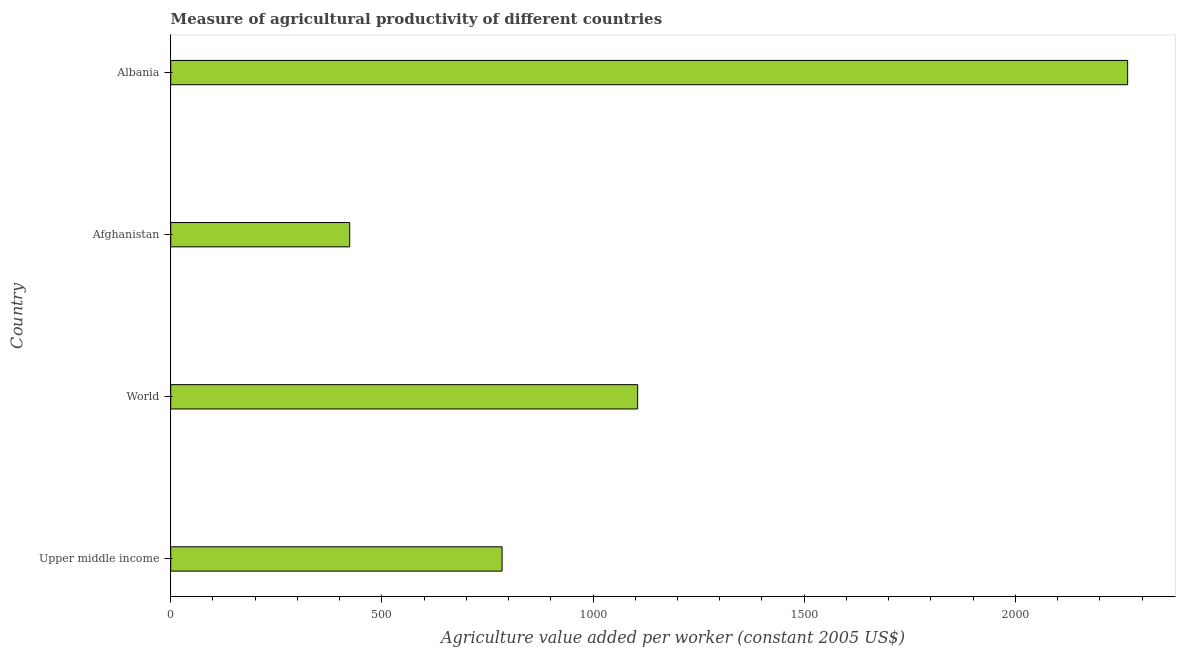Does the graph contain any zero values?
Provide a short and direct response. No. What is the title of the graph?
Your answer should be very brief. Measure of agricultural productivity of different countries. What is the label or title of the X-axis?
Your answer should be very brief. Agriculture value added per worker (constant 2005 US$). What is the agriculture value added per worker in Afghanistan?
Give a very brief answer. 423.78. Across all countries, what is the maximum agriculture value added per worker?
Offer a very short reply. 2265.96. Across all countries, what is the minimum agriculture value added per worker?
Offer a terse response. 423.78. In which country was the agriculture value added per worker maximum?
Your answer should be very brief. Albania. In which country was the agriculture value added per worker minimum?
Offer a terse response. Afghanistan. What is the sum of the agriculture value added per worker?
Give a very brief answer. 4580.12. What is the difference between the agriculture value added per worker in Albania and World?
Ensure brevity in your answer.  1160.29. What is the average agriculture value added per worker per country?
Give a very brief answer. 1145.03. What is the median agriculture value added per worker?
Ensure brevity in your answer.  945.19. What is the ratio of the agriculture value added per worker in Afghanistan to that in Upper middle income?
Offer a very short reply. 0.54. Is the agriculture value added per worker in Albania less than that in World?
Give a very brief answer. No. Is the difference between the agriculture value added per worker in Afghanistan and Albania greater than the difference between any two countries?
Ensure brevity in your answer.  Yes. What is the difference between the highest and the second highest agriculture value added per worker?
Offer a terse response. 1160.29. Is the sum of the agriculture value added per worker in Albania and Upper middle income greater than the maximum agriculture value added per worker across all countries?
Provide a succinct answer. Yes. What is the difference between the highest and the lowest agriculture value added per worker?
Offer a terse response. 1842.19. Are all the bars in the graph horizontal?
Provide a succinct answer. Yes. What is the Agriculture value added per worker (constant 2005 US$) of Upper middle income?
Your answer should be very brief. 784.7. What is the Agriculture value added per worker (constant 2005 US$) of World?
Provide a short and direct response. 1105.68. What is the Agriculture value added per worker (constant 2005 US$) in Afghanistan?
Offer a terse response. 423.78. What is the Agriculture value added per worker (constant 2005 US$) in Albania?
Offer a very short reply. 2265.96. What is the difference between the Agriculture value added per worker (constant 2005 US$) in Upper middle income and World?
Give a very brief answer. -320.98. What is the difference between the Agriculture value added per worker (constant 2005 US$) in Upper middle income and Afghanistan?
Your response must be concise. 360.92. What is the difference between the Agriculture value added per worker (constant 2005 US$) in Upper middle income and Albania?
Provide a short and direct response. -1481.26. What is the difference between the Agriculture value added per worker (constant 2005 US$) in World and Afghanistan?
Make the answer very short. 681.9. What is the difference between the Agriculture value added per worker (constant 2005 US$) in World and Albania?
Offer a very short reply. -1160.28. What is the difference between the Agriculture value added per worker (constant 2005 US$) in Afghanistan and Albania?
Your answer should be very brief. -1842.19. What is the ratio of the Agriculture value added per worker (constant 2005 US$) in Upper middle income to that in World?
Offer a terse response. 0.71. What is the ratio of the Agriculture value added per worker (constant 2005 US$) in Upper middle income to that in Afghanistan?
Provide a succinct answer. 1.85. What is the ratio of the Agriculture value added per worker (constant 2005 US$) in Upper middle income to that in Albania?
Give a very brief answer. 0.35. What is the ratio of the Agriculture value added per worker (constant 2005 US$) in World to that in Afghanistan?
Your answer should be compact. 2.61. What is the ratio of the Agriculture value added per worker (constant 2005 US$) in World to that in Albania?
Your response must be concise. 0.49. What is the ratio of the Agriculture value added per worker (constant 2005 US$) in Afghanistan to that in Albania?
Your response must be concise. 0.19. 